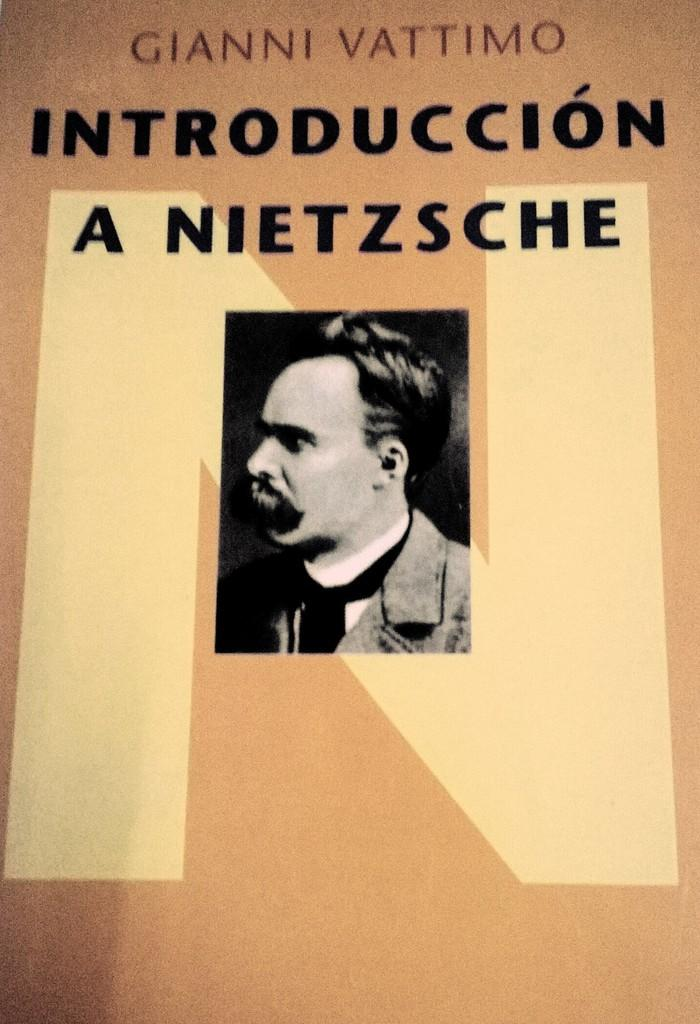What is the main subject of the image? There is a photo in the image. What is depicted in the photo? The photo contains a picture of a man. Are there any additional elements on the photo besides the man's image? Yes, there is text on the photo. What type of stone can be seen in the background of the photo? There is no stone visible in the background of the photo; it only contains a picture of a man and text. Is there a home visible in the photo? No, there is no home depicted in the photo; it only contains a picture of a man and text. 